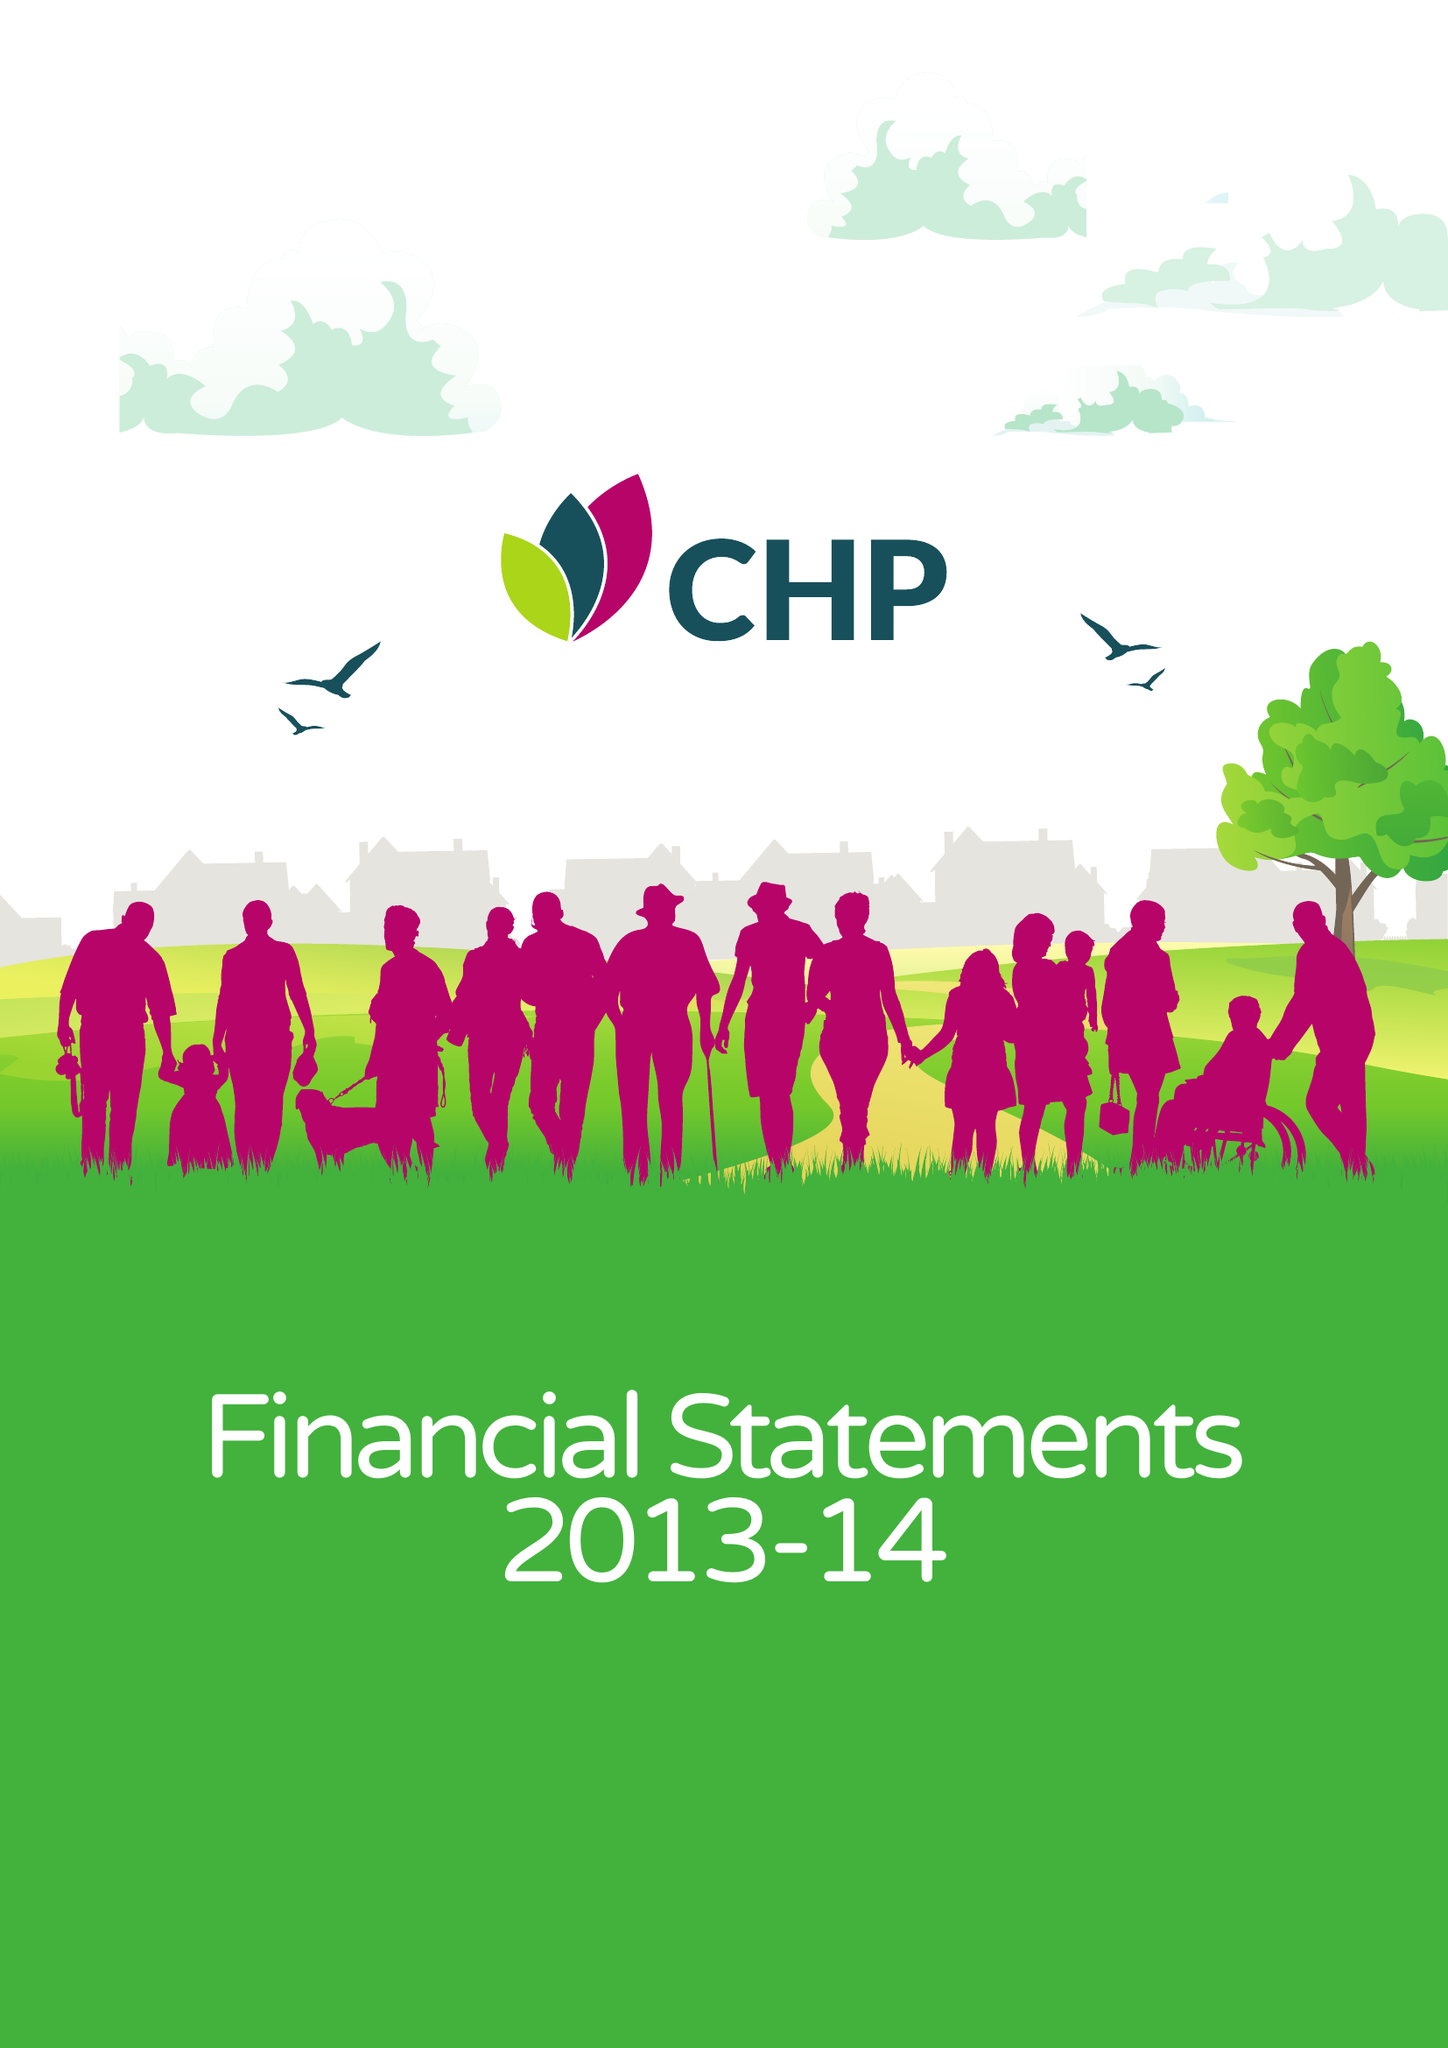What is the value for the address__street_line?
Answer the question using a single word or phrase. None 